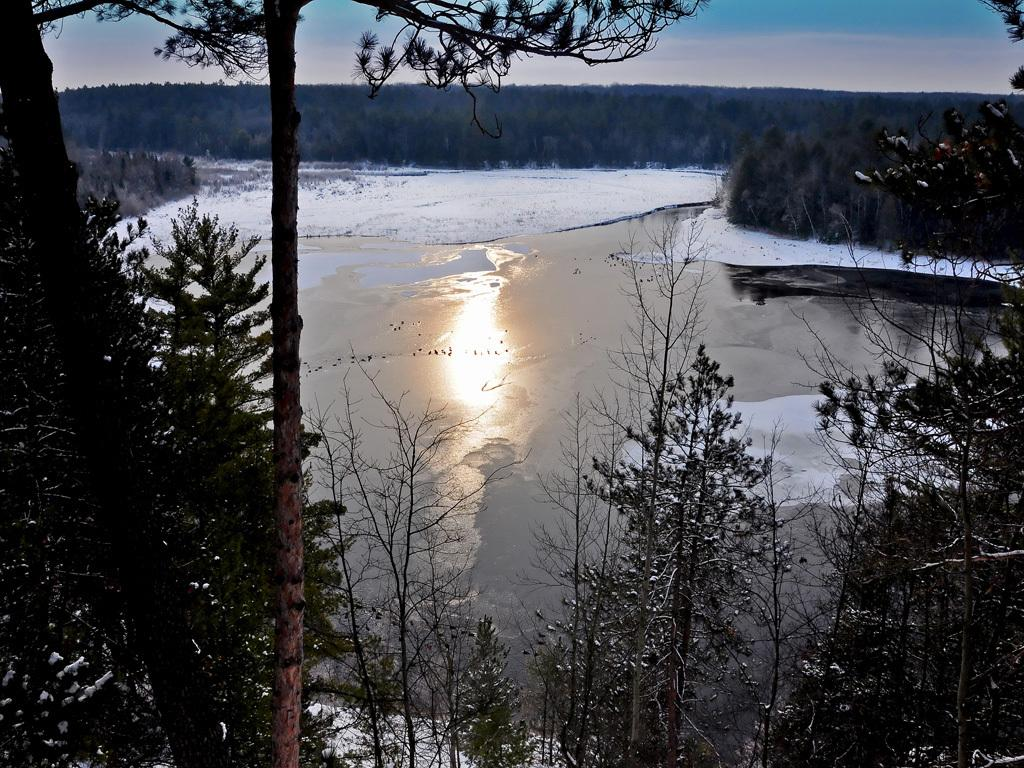What can be seen in the foreground of the picture? There are trees in the foreground of the picture. What is located in the center of the picture? There is a water body in the center of the picture. What can be seen in the background of the picture? There are trees in the background of the picture. What type of metal can be seen in the throat of the water body in the image? There is no metal or throat present in the water body in the image; it is a natural body of water surrounded by trees. 